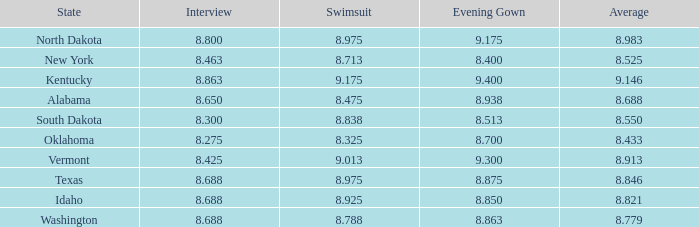846 has? None. Could you parse the entire table? {'header': ['State', 'Interview', 'Swimsuit', 'Evening Gown', 'Average'], 'rows': [['North Dakota', '8.800', '8.975', '9.175', '8.983'], ['New York', '8.463', '8.713', '8.400', '8.525'], ['Kentucky', '8.863', '9.175', '9.400', '9.146'], ['Alabama', '8.650', '8.475', '8.938', '8.688'], ['South Dakota', '8.300', '8.838', '8.513', '8.550'], ['Oklahoma', '8.275', '8.325', '8.700', '8.433'], ['Vermont', '8.425', '9.013', '9.300', '8.913'], ['Texas', '8.688', '8.975', '8.875', '8.846'], ['Idaho', '8.688', '8.925', '8.850', '8.821'], ['Washington', '8.688', '8.788', '8.863', '8.779']]} 